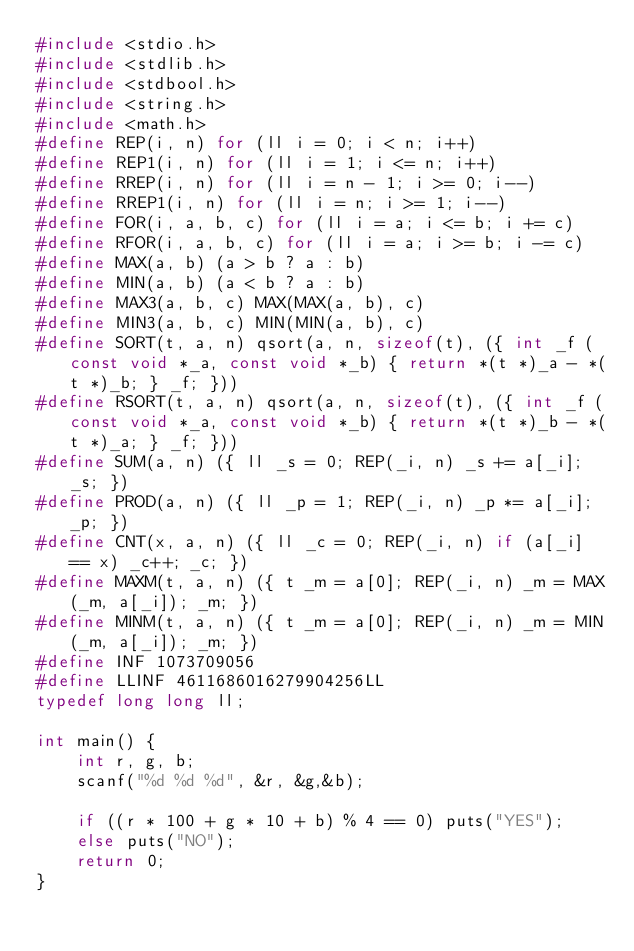<code> <loc_0><loc_0><loc_500><loc_500><_C_>#include <stdio.h>
#include <stdlib.h>
#include <stdbool.h>
#include <string.h>
#include <math.h>
#define REP(i, n) for (ll i = 0; i < n; i++)
#define REP1(i, n) for (ll i = 1; i <= n; i++)
#define RREP(i, n) for (ll i = n - 1; i >= 0; i--)
#define RREP1(i, n) for (ll i = n; i >= 1; i--)
#define FOR(i, a, b, c) for (ll i = a; i <= b; i += c)
#define RFOR(i, a, b, c) for (ll i = a; i >= b; i -= c)
#define MAX(a, b) (a > b ? a : b)
#define MIN(a, b) (a < b ? a : b)
#define MAX3(a, b, c) MAX(MAX(a, b), c)
#define MIN3(a, b, c) MIN(MIN(a, b), c)
#define SORT(t, a, n) qsort(a, n, sizeof(t), ({ int _f (const void *_a, const void *_b) { return *(t *)_a - *(t *)_b; } _f; }))
#define RSORT(t, a, n) qsort(a, n, sizeof(t), ({ int _f (const void *_a, const void *_b) { return *(t *)_b - *(t *)_a; } _f; }))
#define SUM(a, n) ({ ll _s = 0; REP(_i, n) _s += a[_i]; _s; })
#define PROD(a, n) ({ ll _p = 1; REP(_i, n) _p *= a[_i]; _p; })
#define CNT(x, a, n) ({ ll _c = 0; REP(_i, n) if (a[_i] == x) _c++; _c; })
#define MAXM(t, a, n) ({ t _m = a[0]; REP(_i, n) _m = MAX(_m, a[_i]); _m; })
#define MINM(t, a, n) ({ t _m = a[0]; REP(_i, n) _m = MIN(_m, a[_i]); _m; })
#define INF 1073709056
#define LLINF 4611686016279904256LL
typedef long long ll;

int main() {
    int r, g, b;
    scanf("%d %d %d", &r, &g,&b);
    
    if ((r * 100 + g * 10 + b) % 4 == 0) puts("YES");
    else puts("NO");
    return 0;
}</code> 